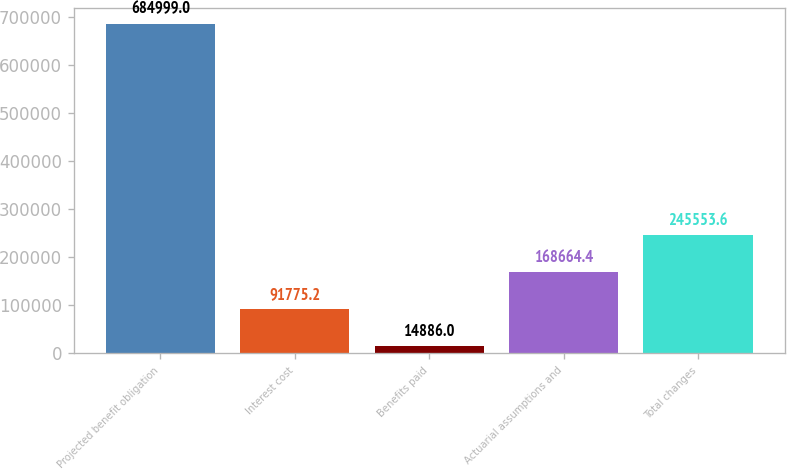Convert chart. <chart><loc_0><loc_0><loc_500><loc_500><bar_chart><fcel>Projected benefit obligation<fcel>Interest cost<fcel>Benefits paid<fcel>Actuarial assumptions and<fcel>Total changes<nl><fcel>684999<fcel>91775.2<fcel>14886<fcel>168664<fcel>245554<nl></chart> 